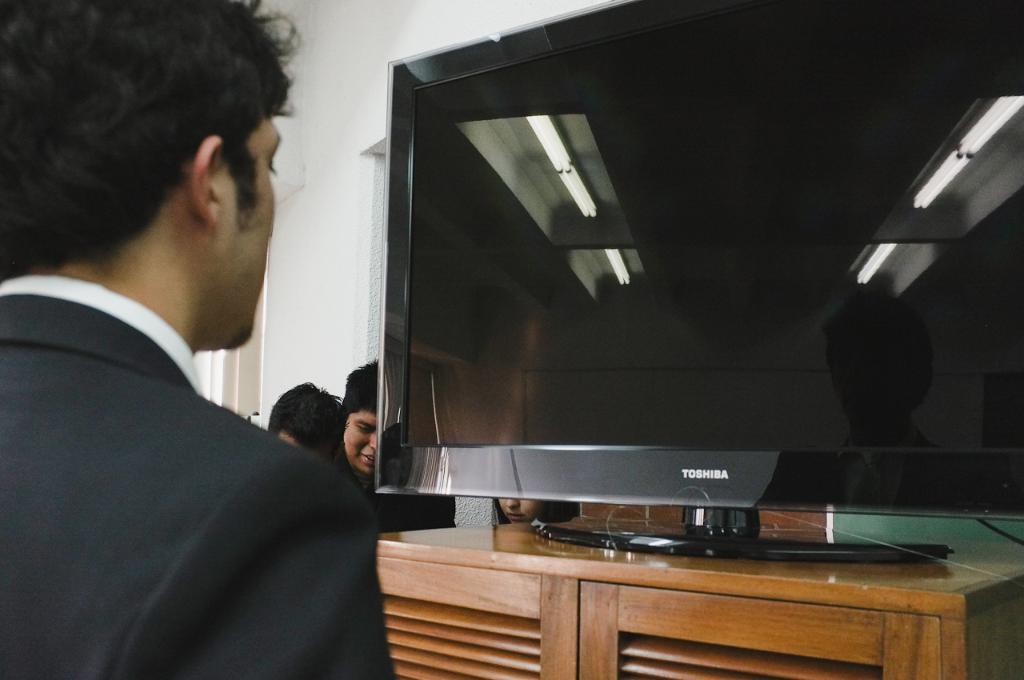Who is on the left side of the image? There is a person on the left side of the image. Can you describe the people in the background of the image? There are people in the background of the image. What electronic device is present in the image? There is a TV on a stand in the image. What type of structure is visible in the image? There is a wall visible in the image. Where is the kettle located in the image? There is no kettle present in the image. Can you describe the bridge in the image? There is no bridge present in the image. 